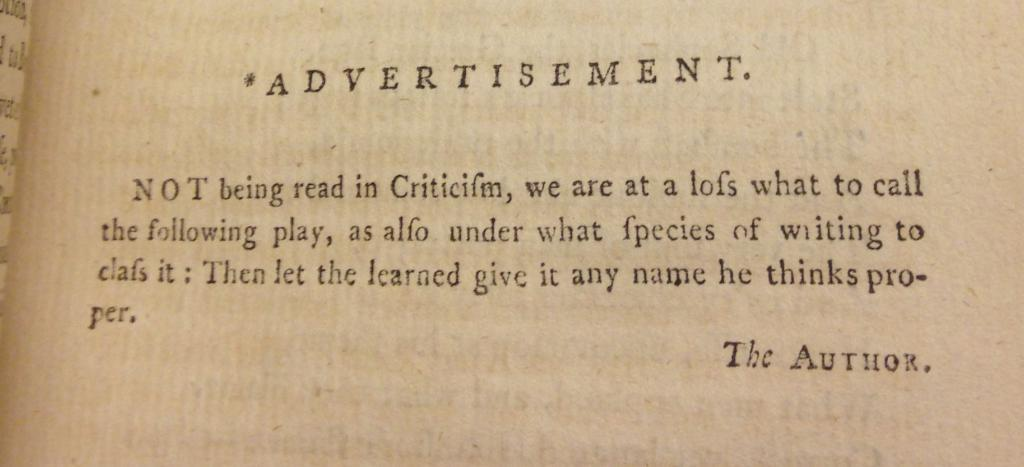<image>
Provide a brief description of the given image. A book open to a page with a heading "Advertisement" from The Author 